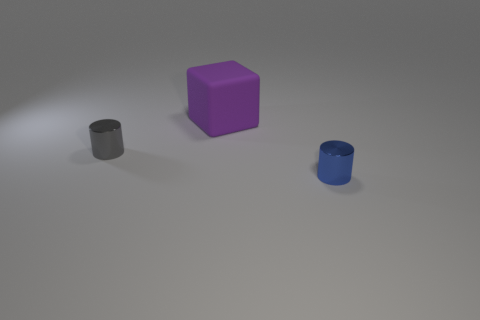Add 2 small cylinders. How many objects exist? 5 Subtract all gray cylinders. How many cylinders are left? 1 Subtract 1 cubes. How many cubes are left? 0 Subtract all red balls. How many gray cylinders are left? 1 Add 1 metal cylinders. How many metal cylinders exist? 3 Subtract 0 gray blocks. How many objects are left? 3 Subtract all cylinders. How many objects are left? 1 Subtract all gray cylinders. Subtract all green balls. How many cylinders are left? 1 Subtract all metallic things. Subtract all big purple blocks. How many objects are left? 0 Add 1 large rubber objects. How many large rubber objects are left? 2 